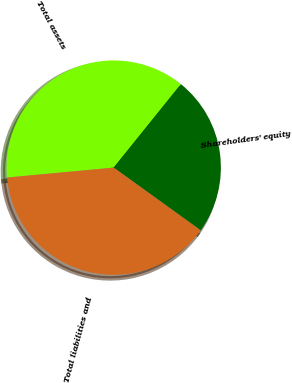Convert chart. <chart><loc_0><loc_0><loc_500><loc_500><pie_chart><fcel>Total assets<fcel>Shareholders' equity<fcel>Total liabilities and<nl><fcel>37.27%<fcel>24.15%<fcel>38.58%<nl></chart> 